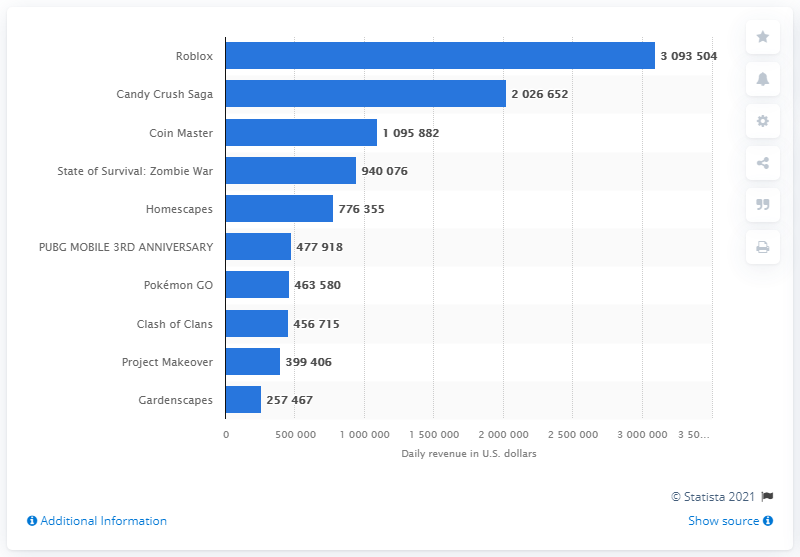Mention a couple of crucial points in this snapshot. The difference between the highest and lowest revenue numbers is 2836037. The second highest grossing game in the U.S. in 2021 was Candy Crush Saga. The bars are in the color of blue. In March 2021, the top-grossing iPhone gaming app in the U.S. was Roblox, generating the highest revenue among all gaming apps available on the App Store. 